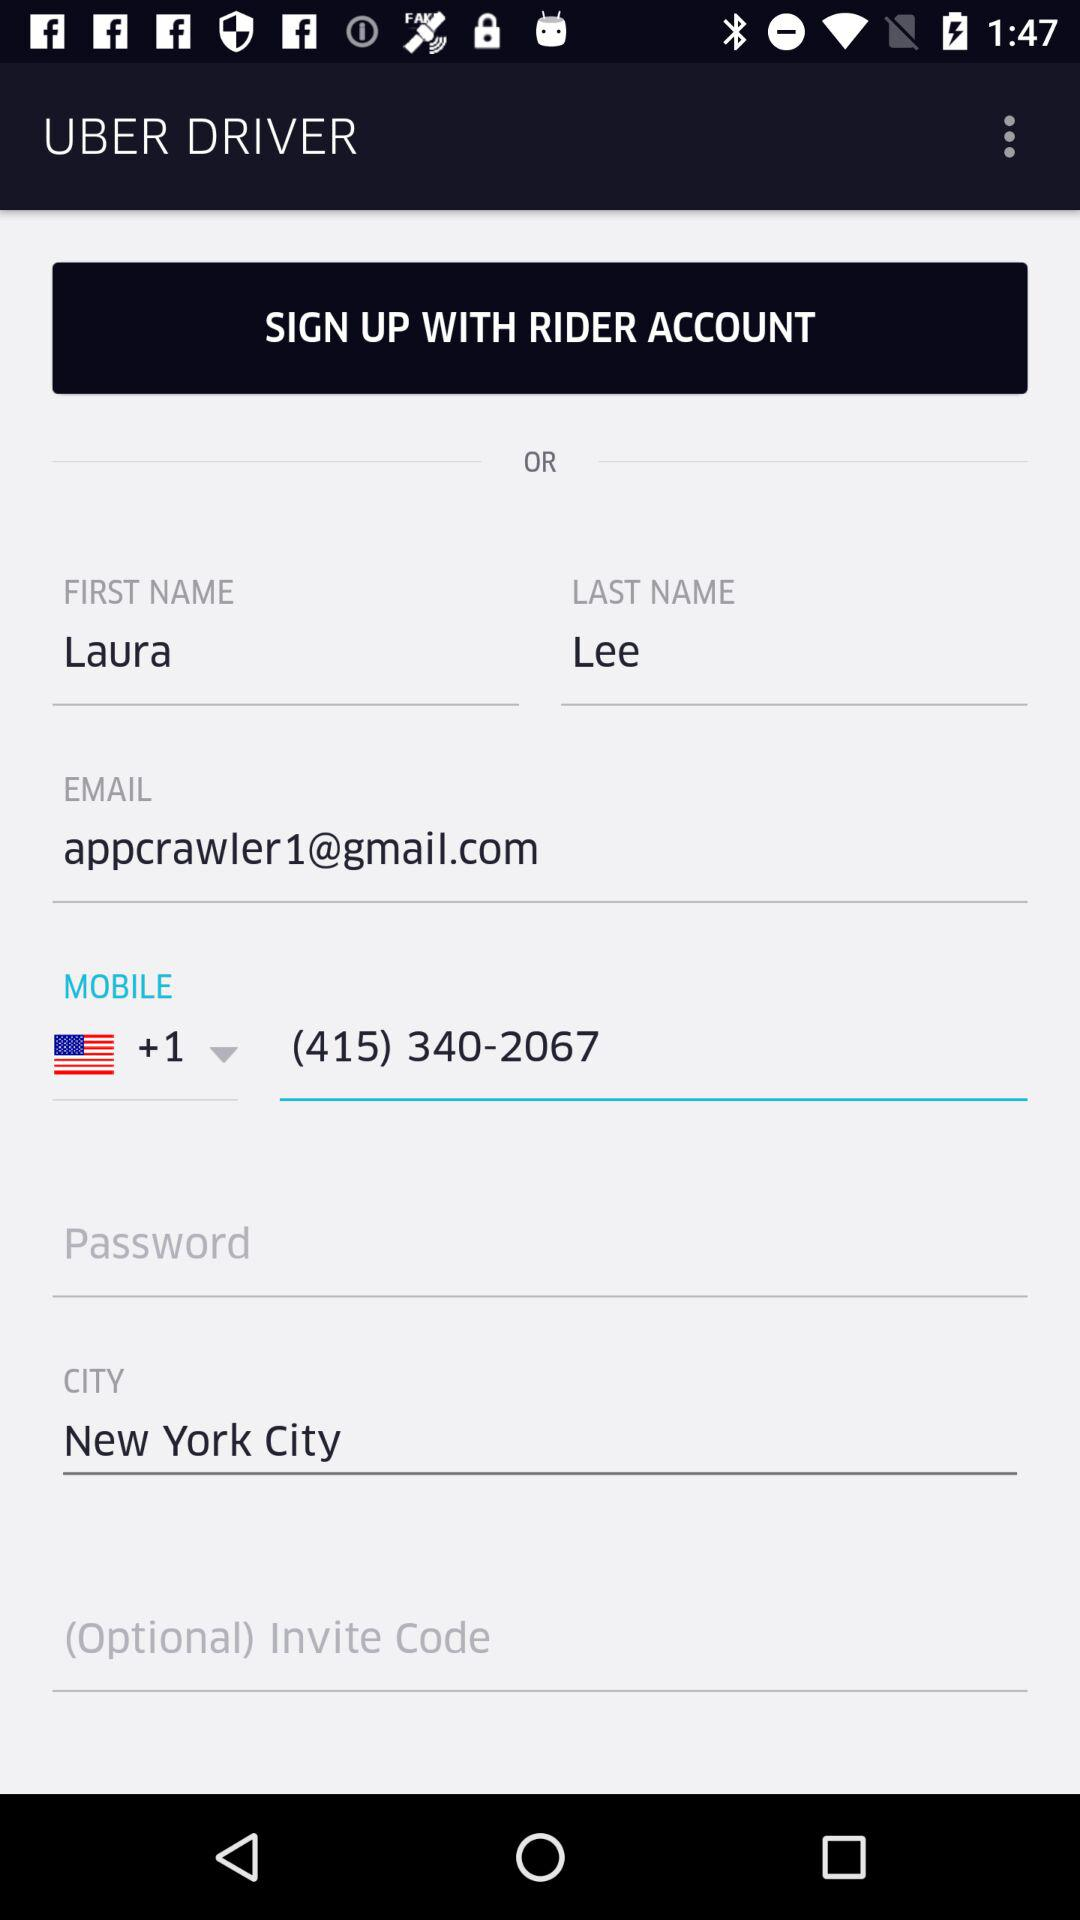What is the first name? The first name is Laura. 